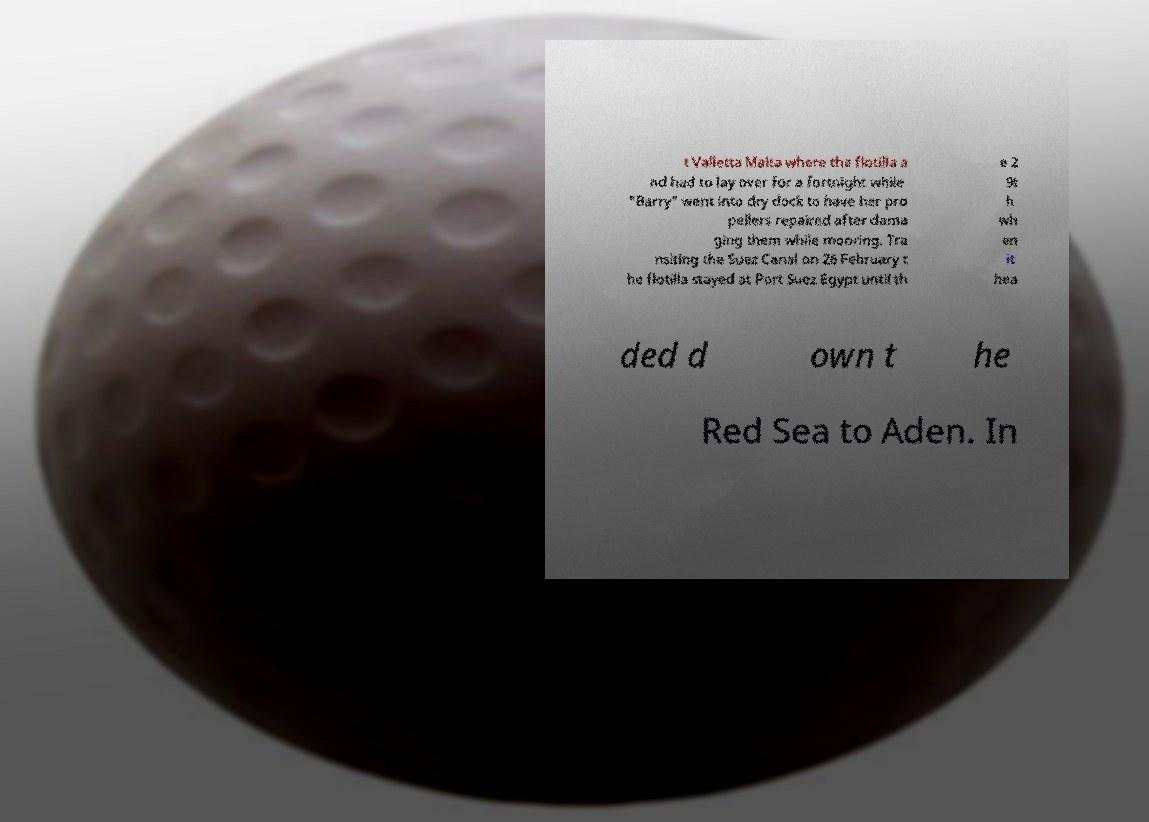Can you accurately transcribe the text from the provided image for me? t Valletta Malta where the flotilla a nd had to lay over for a fortnight while "Barry" went into dry dock to have her pro pellers repaired after dama ging them while mooring. Tra nsiting the Suez Canal on 26 February t he flotilla stayed at Port Suez Egypt until th e 2 9t h wh en it hea ded d own t he Red Sea to Aden. In 